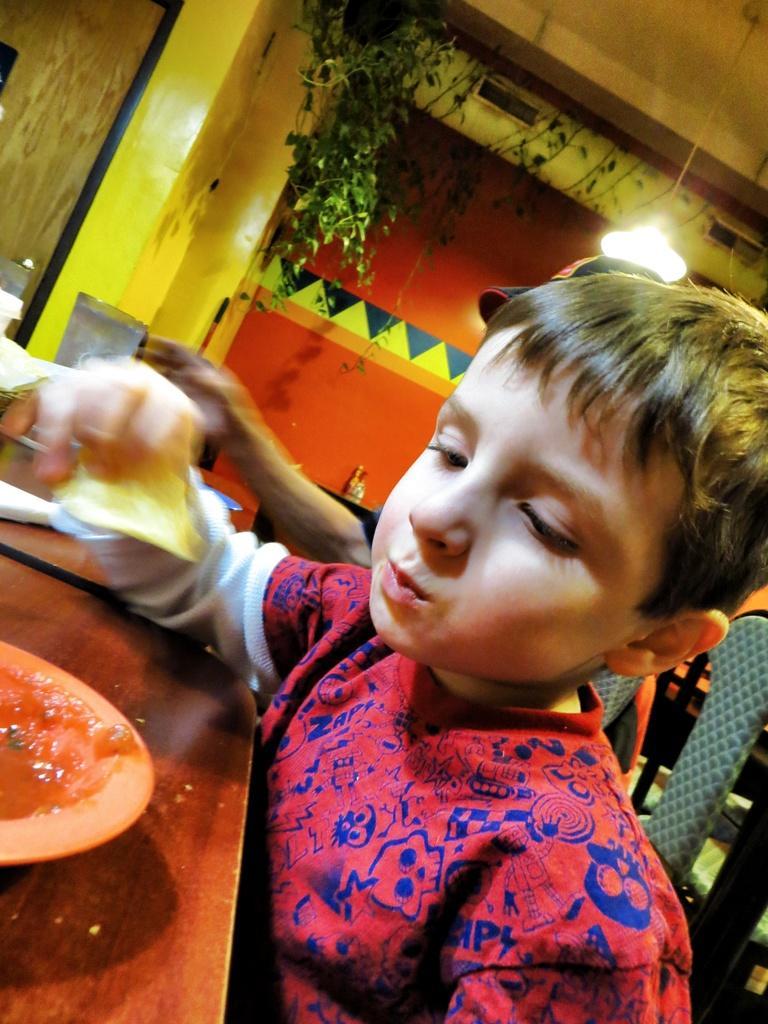Describe this image in one or two sentences. On the right side, there is a child in a red color shirt, sitting on a chair, holding a food item with one hand in front of a table on which, there is a bowl. Beside him, there is another person. In the background, there is a light attached to the roof, there is a plant and there is a wall. 